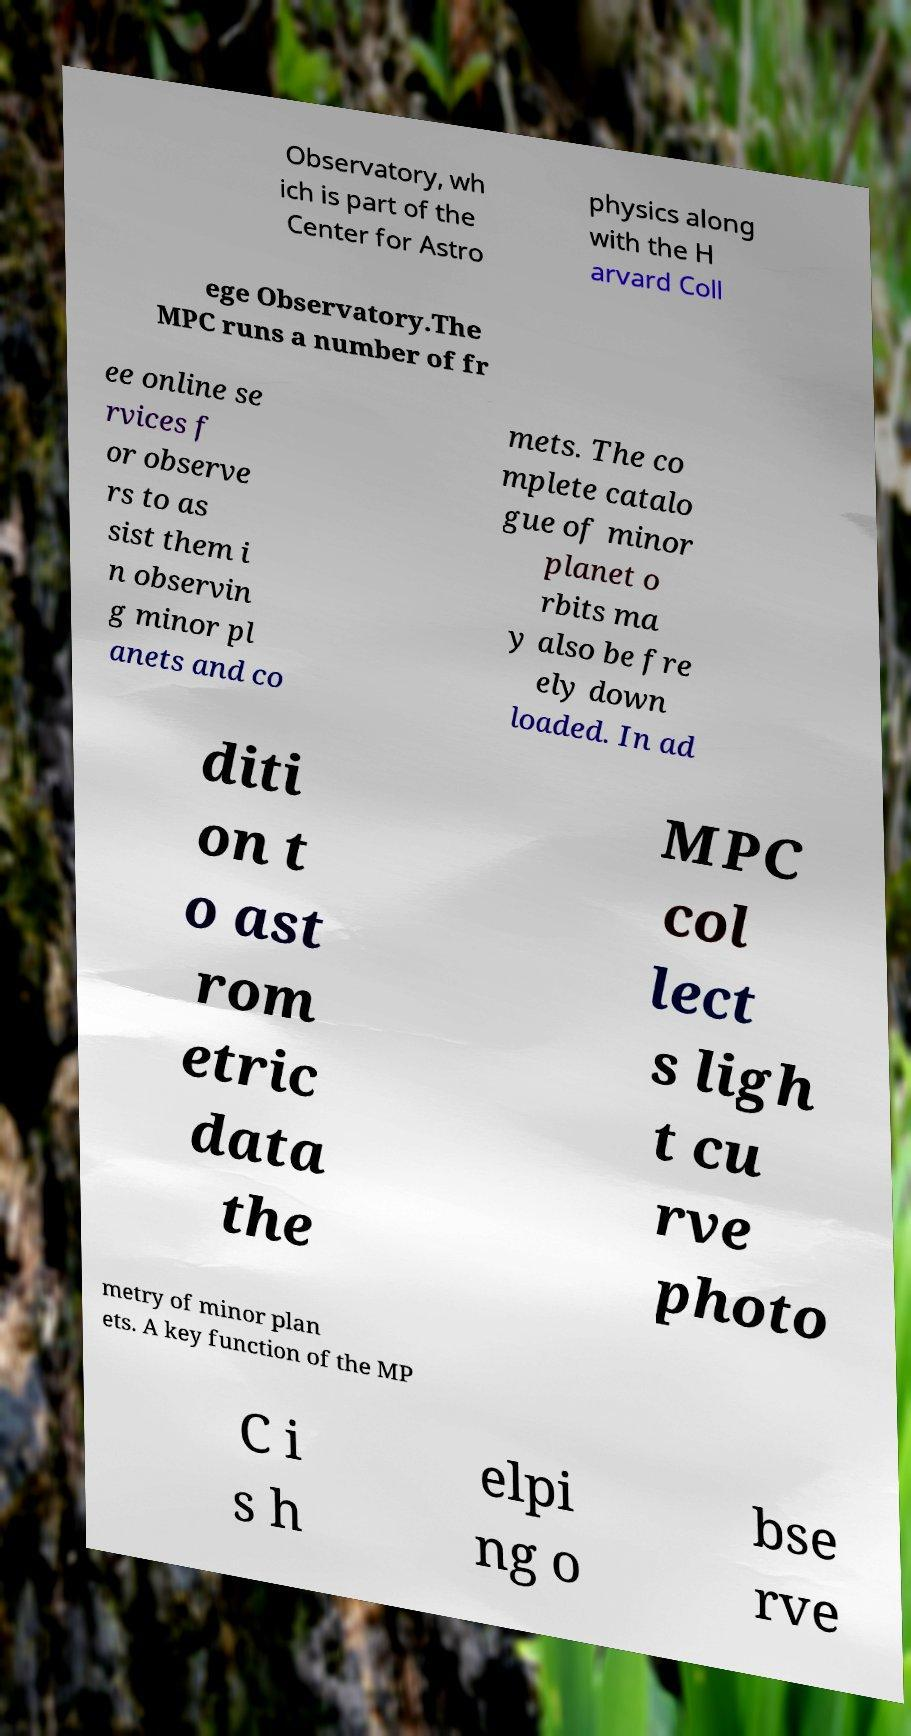Please read and relay the text visible in this image. What does it say? Observatory, wh ich is part of the Center for Astro physics along with the H arvard Coll ege Observatory.The MPC runs a number of fr ee online se rvices f or observe rs to as sist them i n observin g minor pl anets and co mets. The co mplete catalo gue of minor planet o rbits ma y also be fre ely down loaded. In ad diti on t o ast rom etric data the MPC col lect s ligh t cu rve photo metry of minor plan ets. A key function of the MP C i s h elpi ng o bse rve 